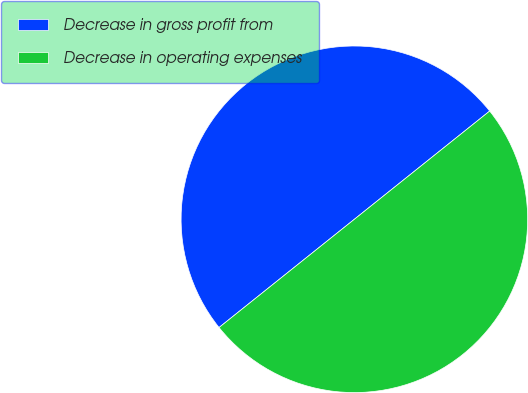Convert chart. <chart><loc_0><loc_0><loc_500><loc_500><pie_chart><fcel>Decrease in gross profit from<fcel>Decrease in operating expenses<nl><fcel>50.0%<fcel>50.0%<nl></chart> 